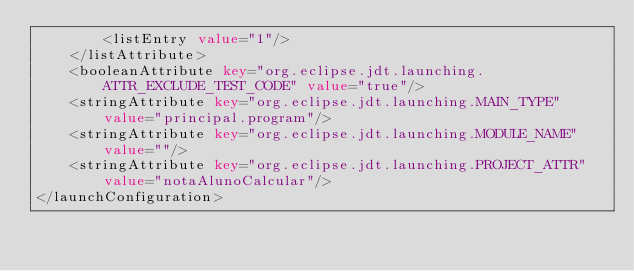<code> <loc_0><loc_0><loc_500><loc_500><_XML_>        <listEntry value="1"/>
    </listAttribute>
    <booleanAttribute key="org.eclipse.jdt.launching.ATTR_EXCLUDE_TEST_CODE" value="true"/>
    <stringAttribute key="org.eclipse.jdt.launching.MAIN_TYPE" value="principal.program"/>
    <stringAttribute key="org.eclipse.jdt.launching.MODULE_NAME" value=""/>
    <stringAttribute key="org.eclipse.jdt.launching.PROJECT_ATTR" value="notaAlunoCalcular"/>
</launchConfiguration>
</code> 